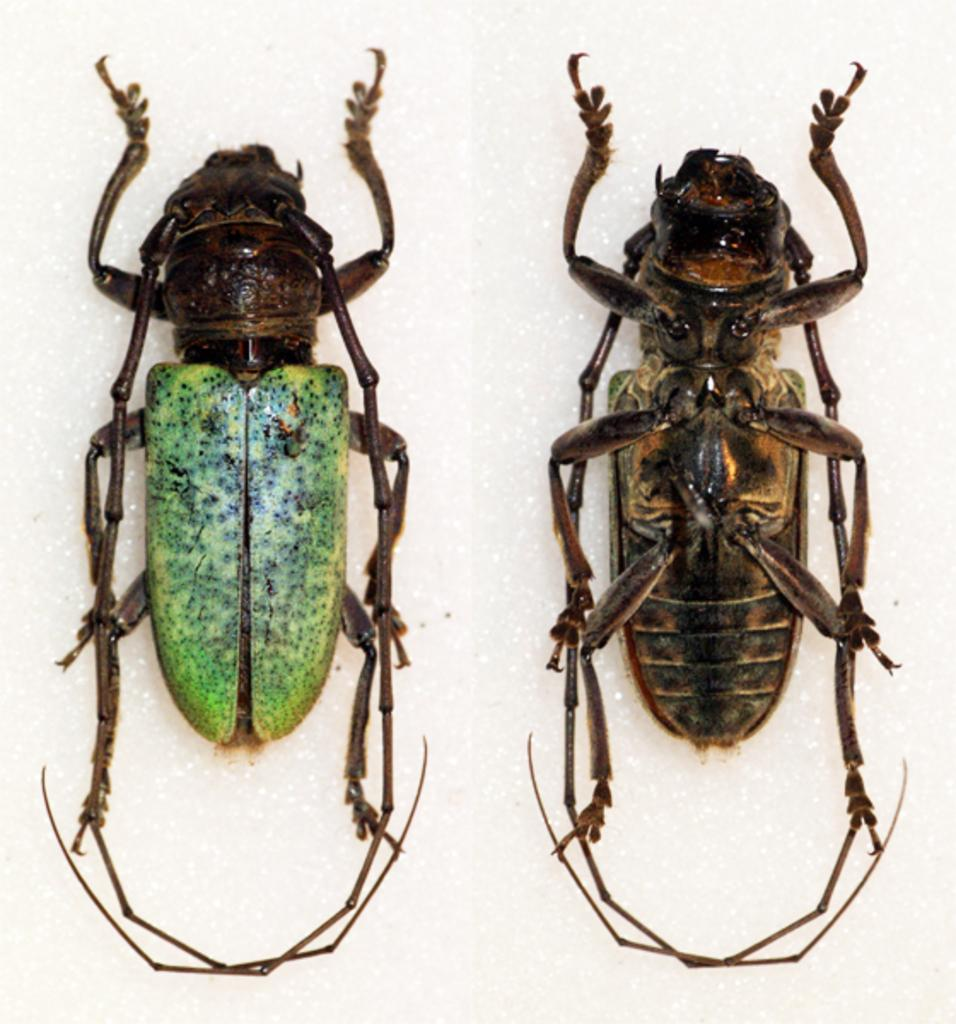What type of insects can be seen in the image? There are two cockroaches in the image. Where are the cockroaches located? The cockroaches are on the floor. Is the woman in the image crying and kicking the cockroaches? There is no woman present in the image, and the cockroaches are not being kicked or cried at. 